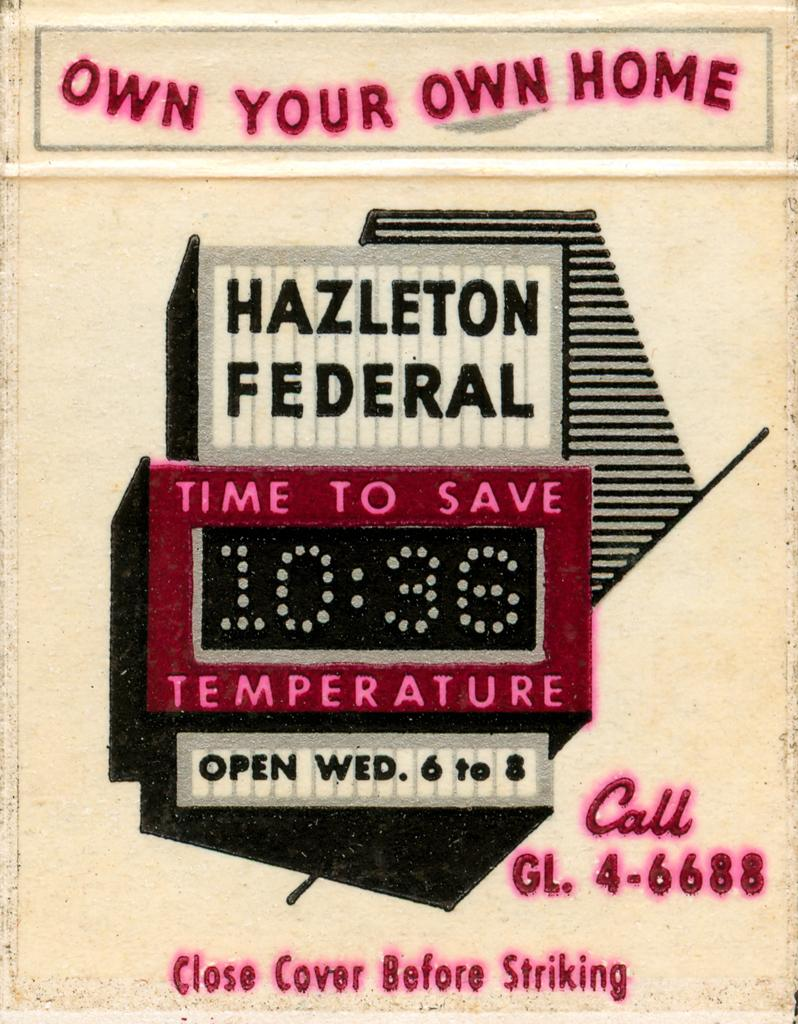<image>
Provide a brief description of the given image. An old flier encouraging people to buy their own home using Hazleton federal. 